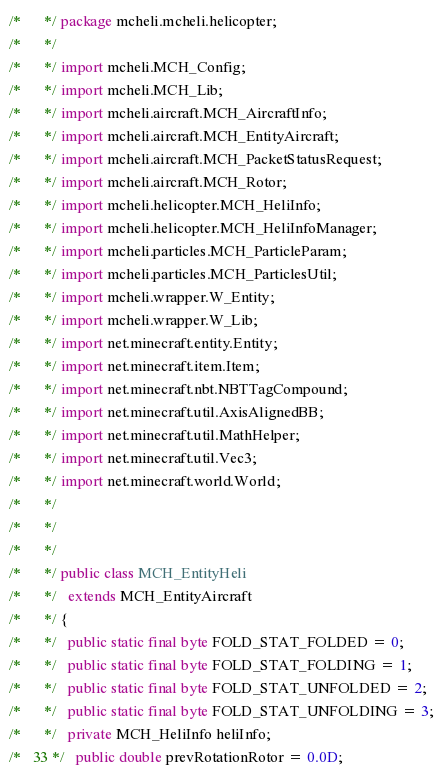<code> <loc_0><loc_0><loc_500><loc_500><_Java_>/*      */ package mcheli.mcheli.helicopter;
/*      */ 
/*      */ import mcheli.MCH_Config;
/*      */ import mcheli.MCH_Lib;
/*      */ import mcheli.aircraft.MCH_AircraftInfo;
/*      */ import mcheli.aircraft.MCH_EntityAircraft;
/*      */ import mcheli.aircraft.MCH_PacketStatusRequest;
/*      */ import mcheli.aircraft.MCH_Rotor;
/*      */ import mcheli.helicopter.MCH_HeliInfo;
/*      */ import mcheli.helicopter.MCH_HeliInfoManager;
/*      */ import mcheli.particles.MCH_ParticleParam;
/*      */ import mcheli.particles.MCH_ParticlesUtil;
/*      */ import mcheli.wrapper.W_Entity;
/*      */ import mcheli.wrapper.W_Lib;
/*      */ import net.minecraft.entity.Entity;
/*      */ import net.minecraft.item.Item;
/*      */ import net.minecraft.nbt.NBTTagCompound;
/*      */ import net.minecraft.util.AxisAlignedBB;
/*      */ import net.minecraft.util.MathHelper;
/*      */ import net.minecraft.util.Vec3;
/*      */ import net.minecraft.world.World;
/*      */ 
/*      */ 
/*      */ 
/*      */ public class MCH_EntityHeli
/*      */   extends MCH_EntityAircraft
/*      */ {
/*      */   public static final byte FOLD_STAT_FOLDED = 0;
/*      */   public static final byte FOLD_STAT_FOLDING = 1;
/*      */   public static final byte FOLD_STAT_UNFOLDED = 2;
/*      */   public static final byte FOLD_STAT_UNFOLDING = 3;
/*      */   private MCH_HeliInfo heliInfo;
/*   33 */   public double prevRotationRotor = 0.0D;</code> 